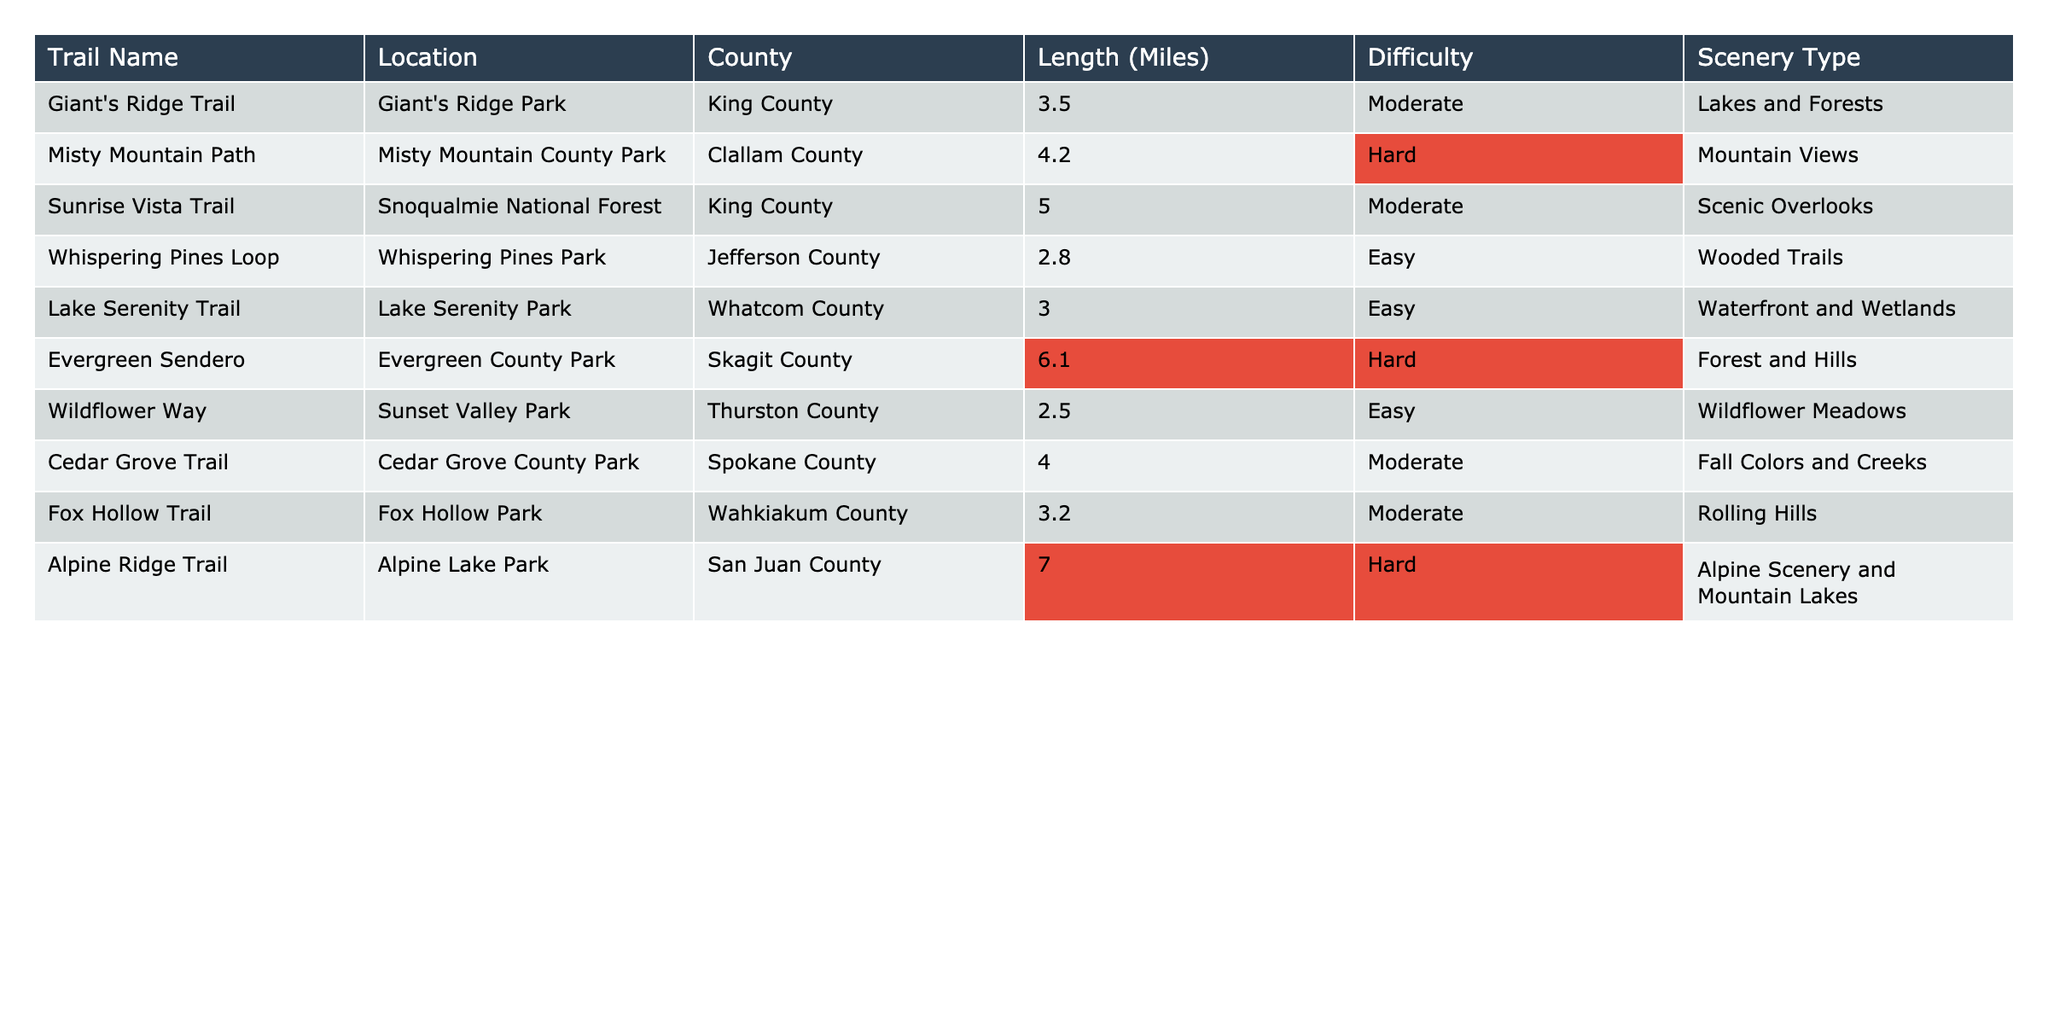What is the longest hiking trail listed? The trail with the greatest length in the table is "Alpine Ridge Trail" which measures 7.0 miles.
Answer: 7.0 miles Which trail has the shortest length? By examining the lengths of each trail, "Wildflower Way" is the shortest at 2.5 miles.
Answer: 2.5 miles How many trails are marked as "Hard" difficulty? There are three trails labeled as "Hard" difficulty: "Misty Mountain Path," "Evergreen Sendero," and "Alpine Ridge Trail."
Answer: 3 What trail has a scenic view that includes both lakes and forests? The "Giant's Ridge Trail" provides scenic views of lakes and forests, as indicated in the table.
Answer: Giant's Ridge Trail What is the average length of all trails listed? To find the average length, we sum all trail lengths (3.5 + 4.2 + 5.0 + 2.8 + 3.0 + 6.1 + 2.5 + 4.0 + 3.2 + 7.0 = 42.3) and divide by the number of trails (10), resulting in 42.3 / 10 = 4.23 miles.
Answer: 4.23 miles Is "Whispering Pines Loop" considered an easy trail? Yes, "Whispering Pines Loop" is categorized as "Easy" difficulty according to the table.
Answer: Yes Which county has the most trails listed in the table? The table shows trails from various counties, and King County has the most trails listed, with a total of three: "Giant's Ridge Trail," "Sunrise Vista Trail," and "Alpine Ridge Trail."
Answer: King County How many trails are categorized as "Easy" difficulty? Four trails are categorized as easy: "Whispering Pines Loop," "Lake Serenity Trail," "Wildflower Way," and "Fox Hollow Trail."
Answer: 4 What is the total length of all "Moderate" trails? The lengths of "Moderate" trails are "Giant's Ridge Trail" (3.5), "Sunrise Vista Trail" (5.0), "Cedar Grove Trail" (4.0), and "Fox Hollow Trail" (3.2). Adding these lengths gives a total of 3.5 + 5.0 + 4.0 + 3.2 = 15.7 miles.
Answer: 15.7 miles Are there any trails with a scenery type of "Waterfront and Wetlands"? Yes, "Lake Serenity Trail" is noted for having a scenery type of "Waterfront and Wetlands."
Answer: Yes 